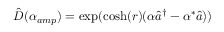Convert formula to latex. <formula><loc_0><loc_0><loc_500><loc_500>\hat { D } ( \alpha _ { a m p } ) = \exp ( \cosh ( r ) ( \alpha \hat { a } ^ { \dagger } - \alpha ^ { * } \hat { a } ) )</formula> 